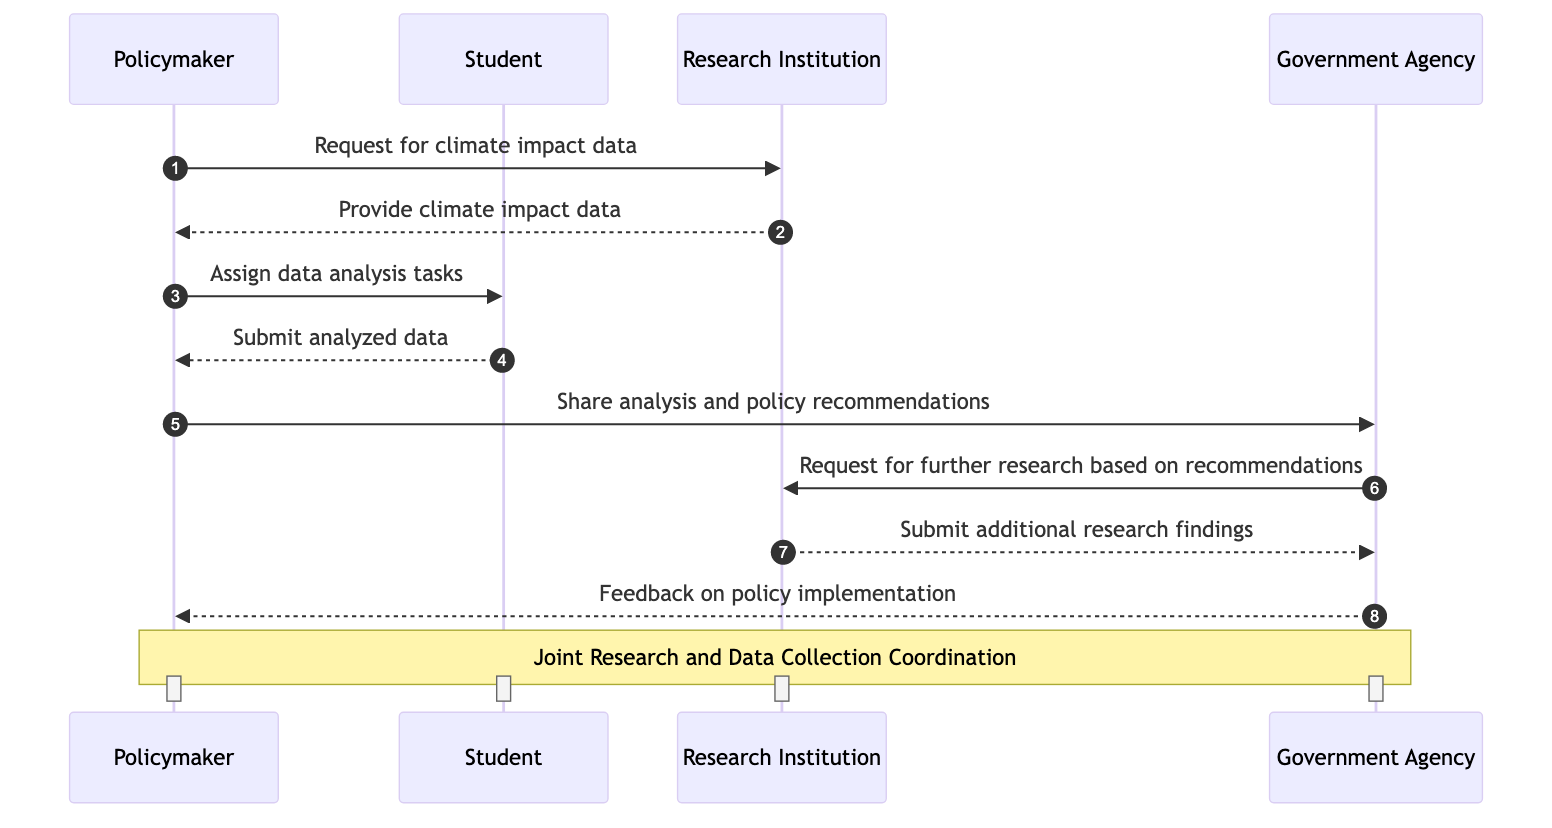What is the first message in the sequence? The first message is sent from the Policymaker to the Research Institution, requesting climate impact data.
Answer: Request for climate impact data How many actors are involved in the sequence diagram? There are four actors involved: Policymaker, Student, Research Institution, and Government Agency.
Answer: Four What type of data does the Policymaker request from the Research Institution? The Policymaker requests climate impact data from the Research Institution.
Answer: Climate impact data What action occurs after the Student submits analyzed data? After the Student submits the analyzed data, the Policymaker shares analysis and policy recommendations with the Government Agency.
Answer: Share analysis and policy recommendations Who provides additional research findings to the Government Agency? The Research Institution provides additional research findings to the Government Agency after being requested.
Answer: Research Institution What is the last action taken in the sequence diagram? The last action is feedback being provided from the Government Agency to the Policymaker regarding policy implementation.
Answer: Feedback on policy implementation Which actor receives feedback on policy implementation? The Policymaker receives feedback on policy implementation from the Government Agency.
Answer: Policymaker What is the purpose mentioned in the note over the Policymaker and Government Agency? The note indicates that the overall purpose is for joint research and data collection coordination.
Answer: Joint Research and Data Collection Coordination How many messages are exchanged between the Policymaker and the Research Institution? There are two messages exchanged between the Policymaker and the Research Institution.
Answer: Two 